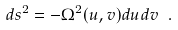Convert formula to latex. <formula><loc_0><loc_0><loc_500><loc_500>d s ^ { 2 } = - \Omega ^ { 2 } ( u , v ) d u d v \ .</formula> 